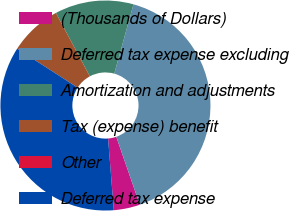Convert chart. <chart><loc_0><loc_0><loc_500><loc_500><pie_chart><fcel>(Thousands of Dollars)<fcel>Deferred tax expense excluding<fcel>Amortization and adjustments<fcel>Tax (expense) benefit<fcel>Other<fcel>Deferred tax expense<nl><fcel>4.04%<fcel>40.39%<fcel>12.12%<fcel>8.08%<fcel>0.0%<fcel>35.38%<nl></chart> 